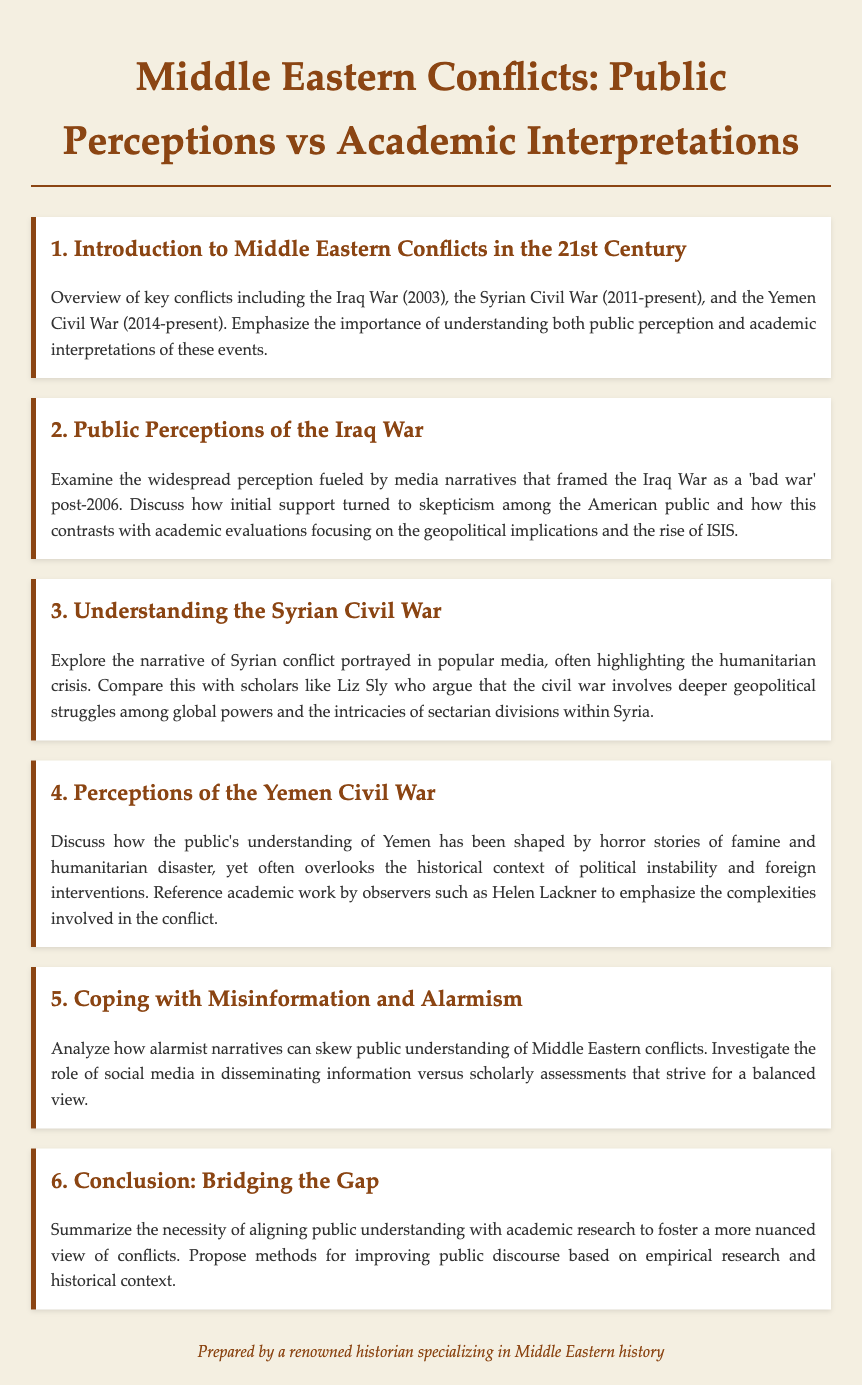What is the title of the document? The title is specified at the beginning of the document and is "Middle Eastern Conflicts: Public Perceptions vs Academic Interpretations."
Answer: Middle Eastern Conflicts: Public Perceptions vs Academic Interpretations When did the Syrian Civil War start? The document mentions the beginning date of the Syrian Civil War in the agenda item focusing on it, which is 2011.
Answer: 2011 Who is referenced in the document as discussing the complexities of the Yemen Civil War? The document names Helen Lackner as an observer of the Yemen Civil War.
Answer: Helen Lackner What has shaped public perception of the Iraq War according to the document? The document states that perceived media narratives framing the Iraq War as a 'bad war' influenced public perception post-2006.
Answer: Media narratives What is the main focus of the document's Conclusion section? The Conclusion emphasizes aligning public understanding with academic research to foster a more nuanced view of conflicts.
Answer: Aligning public understanding with academic research What conflict does the document associate with the rise of ISIS? The document discusses the Iraq War in relation to the rise of ISIS.
Answer: Iraq War 